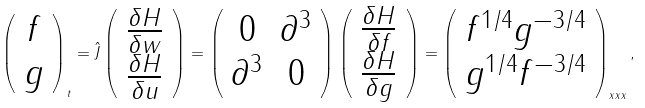<formula> <loc_0><loc_0><loc_500><loc_500>\left ( \begin{array} { c } f \\ g \end{array} \right ) _ { t } = \hat { J } \left ( \begin{array} { c } \frac { \delta H } { \delta w } \\ \frac { \delta H } { \delta u } \end{array} \right ) = \left ( \begin{array} { c c } 0 & \partial ^ { 3 } \\ \partial ^ { 3 } & 0 \end{array} \right ) \left ( \begin{array} { c } \frac { \delta H } { \delta f } \\ \frac { \delta H } { \delta g } \end{array} \right ) = \left ( \begin{array} { c } f ^ { { 1 } / { 4 } } g ^ { - { 3 } / { 4 } } \\ g ^ { { 1 } / { 4 } } f ^ { - { 3 } / { 4 } } \end{array} \right ) _ { x x x } ,</formula> 